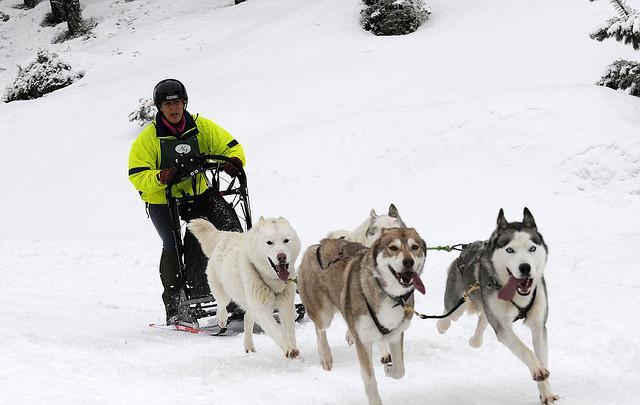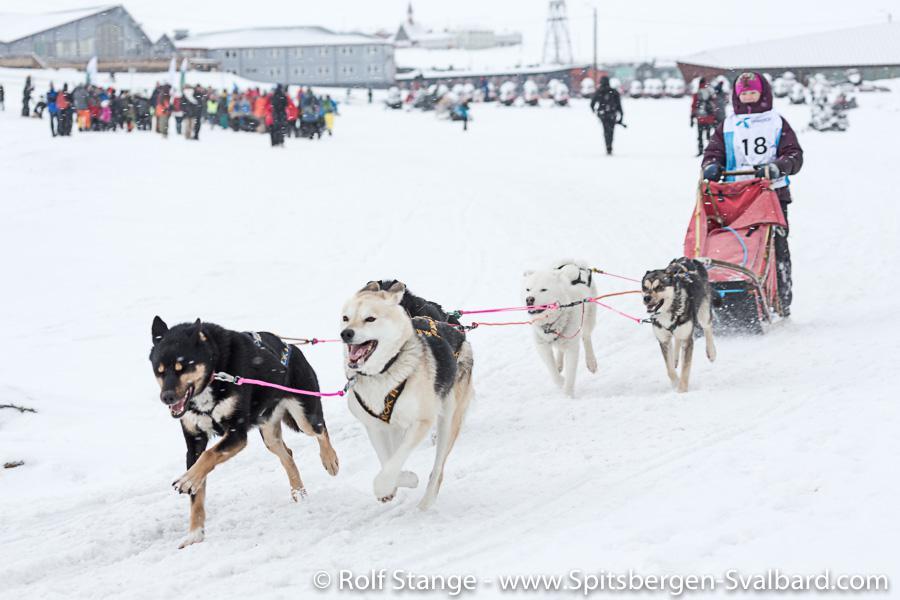The first image is the image on the left, the second image is the image on the right. Evaluate the accuracy of this statement regarding the images: "One of the images features two people riding a single sled.". Is it true? Answer yes or no. No. The first image is the image on the left, the second image is the image on the right. Evaluate the accuracy of this statement regarding the images: "The dog sled teams in the left and right images are moving forward and are angled so they head toward each other.". Is it true? Answer yes or no. Yes. 